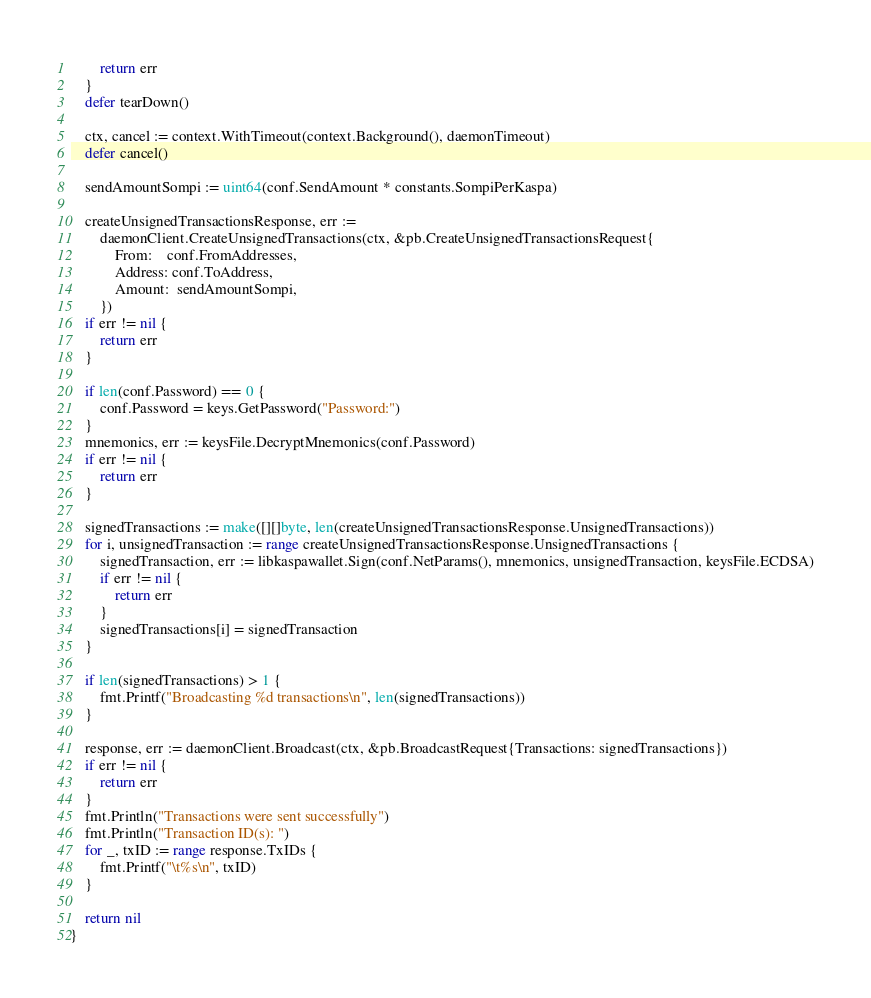Convert code to text. <code><loc_0><loc_0><loc_500><loc_500><_Go_>		return err
	}
	defer tearDown()

	ctx, cancel := context.WithTimeout(context.Background(), daemonTimeout)
	defer cancel()

	sendAmountSompi := uint64(conf.SendAmount * constants.SompiPerKaspa)

	createUnsignedTransactionsResponse, err :=
		daemonClient.CreateUnsignedTransactions(ctx, &pb.CreateUnsignedTransactionsRequest{
			From:    conf.FromAddresses,
			Address: conf.ToAddress,
			Amount:  sendAmountSompi,
		})
	if err != nil {
		return err
	}

	if len(conf.Password) == 0 {
		conf.Password = keys.GetPassword("Password:")
	}
	mnemonics, err := keysFile.DecryptMnemonics(conf.Password)
	if err != nil {
		return err
	}

	signedTransactions := make([][]byte, len(createUnsignedTransactionsResponse.UnsignedTransactions))
	for i, unsignedTransaction := range createUnsignedTransactionsResponse.UnsignedTransactions {
		signedTransaction, err := libkaspawallet.Sign(conf.NetParams(), mnemonics, unsignedTransaction, keysFile.ECDSA)
		if err != nil {
			return err
		}
		signedTransactions[i] = signedTransaction
	}

	if len(signedTransactions) > 1 {
		fmt.Printf("Broadcasting %d transactions\n", len(signedTransactions))
	}

	response, err := daemonClient.Broadcast(ctx, &pb.BroadcastRequest{Transactions: signedTransactions})
	if err != nil {
		return err
	}
	fmt.Println("Transactions were sent successfully")
	fmt.Println("Transaction ID(s): ")
	for _, txID := range response.TxIDs {
		fmt.Printf("\t%s\n", txID)
	}

	return nil
}
</code> 